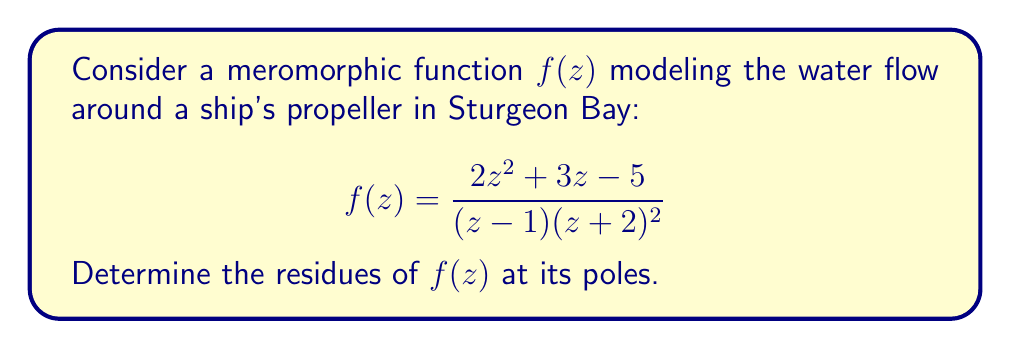Could you help me with this problem? To find the residues of $f(z)$, we need to identify its poles and calculate the residue at each pole.

1. Identify the poles:
   The poles of $f(z)$ occur where the denominator is zero:
   $(z-1)(z+2)^2 = 0$
   This gives us two poles: $z = 1$ (simple pole) and $z = -2$ (double pole)

2. Calculate the residue at $z = 1$ (simple pole):
   For a simple pole, we can use the formula:
   $$\text{Res}(f, 1) = \lim_{z \to 1} (z-1)f(z)$$
   
   $$\begin{align*}
   \text{Res}(f, 1) &= \lim_{z \to 1} (z-1)\frac{2z^2 + 3z - 5}{(z-1)(z+2)^2} \\
   &= \lim_{z \to 1} \frac{2z^2 + 3z - 5}{(z+2)^2} \\
   &= \frac{2(1)^2 + 3(1) - 5}{(1+2)^2} \\
   &= \frac{0}{9} = 0
   \end{align*}$$

3. Calculate the residue at $z = -2$ (double pole):
   For a double pole, we use the formula:
   $$\text{Res}(f, -2) = \lim_{z \to -2} \frac{d}{dz}[(z+2)^2f(z)]$$
   
   Let $g(z) = (z+2)^2f(z) = \frac{2z^2 + 3z - 5}{z-1}$
   
   $$\begin{align*}
   \frac{d}{dz}g(z) &= \frac{(4z+3)(z-1) - (2z^2+3z-5)}{(z-1)^2} \\
   \text{Res}(f, -2) &= \lim_{z \to -2} \frac{(4z+3)(z-1) - (2z^2+3z-5)}{(z-1)^2} \\
   &= \frac{(4(-2)+3)((-2)-1) - (2(-2)^2+3(-2)-5)}{((-2)-1)^2} \\
   &= \frac{(-5)(-3) - (8-6-5)}{(-3)^2} \\
   &= \frac{15 - (-3)}{9} = \frac{18}{9} = 2
   \end{align*}$$
Answer: The residues of $f(z)$ are:
$\text{Res}(f, 1) = 0$ and $\text{Res}(f, -2) = 2$ 